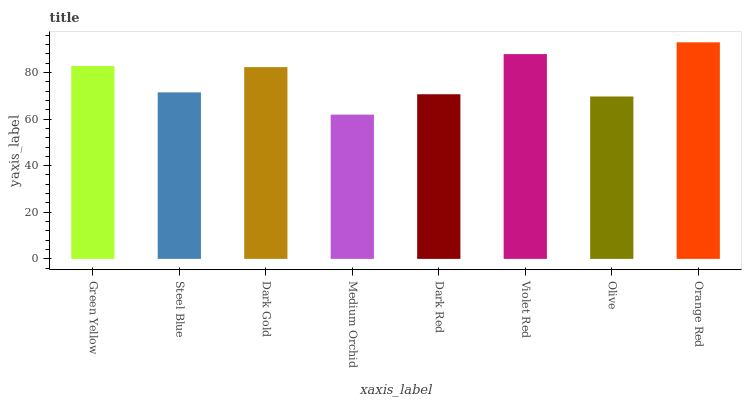Is Steel Blue the minimum?
Answer yes or no. No. Is Steel Blue the maximum?
Answer yes or no. No. Is Green Yellow greater than Steel Blue?
Answer yes or no. Yes. Is Steel Blue less than Green Yellow?
Answer yes or no. Yes. Is Steel Blue greater than Green Yellow?
Answer yes or no. No. Is Green Yellow less than Steel Blue?
Answer yes or no. No. Is Dark Gold the high median?
Answer yes or no. Yes. Is Steel Blue the low median?
Answer yes or no. Yes. Is Orange Red the high median?
Answer yes or no. No. Is Violet Red the low median?
Answer yes or no. No. 